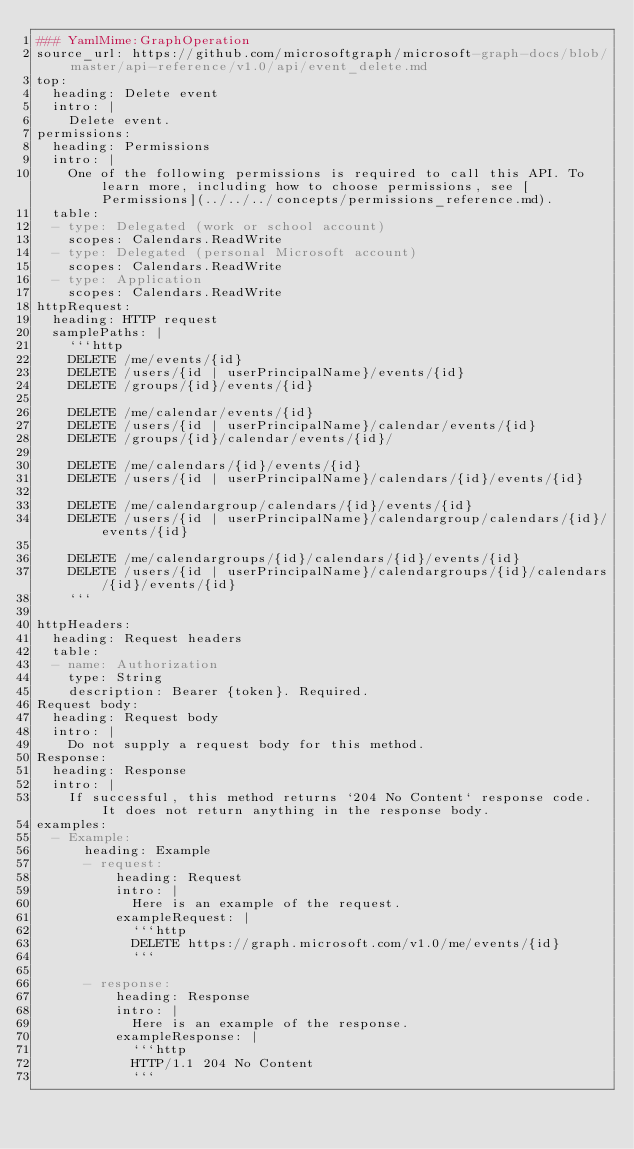Convert code to text. <code><loc_0><loc_0><loc_500><loc_500><_YAML_>### YamlMime:GraphOperation
source_url: https://github.com/microsoftgraph/microsoft-graph-docs/blob/master/api-reference/v1.0/api/event_delete.md
top:
  heading: Delete event
  intro: |
    Delete event.
permissions:
  heading: Permissions
  intro: |
    One of the following permissions is required to call this API. To learn more, including how to choose permissions, see [Permissions](../../../concepts/permissions_reference.md).
  table:
  - type: Delegated (work or school account)
    scopes: Calendars.ReadWrite
  - type: Delegated (personal Microsoft account)
    scopes: Calendars.ReadWrite
  - type: Application
    scopes: Calendars.ReadWrite
httpRequest:
  heading: HTTP request
  samplePaths: |
    ```http
    DELETE /me/events/{id}
    DELETE /users/{id | userPrincipalName}/events/{id}
    DELETE /groups/{id}/events/{id}
    
    DELETE /me/calendar/events/{id}
    DELETE /users/{id | userPrincipalName}/calendar/events/{id}
    DELETE /groups/{id}/calendar/events/{id}/
    
    DELETE /me/calendars/{id}/events/{id}
    DELETE /users/{id | userPrincipalName}/calendars/{id}/events/{id}
    
    DELETE /me/calendargroup/calendars/{id}/events/{id}
    DELETE /users/{id | userPrincipalName}/calendargroup/calendars/{id}/events/{id}
    
    DELETE /me/calendargroups/{id}/calendars/{id}/events/{id}
    DELETE /users/{id | userPrincipalName}/calendargroups/{id}/calendars/{id}/events/{id}
    ```
    
httpHeaders:
  heading: Request headers
  table:
  - name: Authorization
    type: String
    description: Bearer {token}. Required.
Request body:
  heading: Request body
  intro: |
    Do not supply a request body for this method.
Response:
  heading: Response
  intro: |
    If successful, this method returns `204 No Content` response code. It does not return anything in the response body.
examples:
  - Example:
      heading: Example
      - request:
          heading: Request
          intro: |
            Here is an example of the request.
          exampleRequest: |
            ```http
            DELETE https://graph.microsoft.com/v1.0/me/events/{id}
            ```
            
      - response:
          heading: Response
          intro: |
            Here is an example of the response. 
          exampleResponse: |
            ```http
            HTTP/1.1 204 No Content
            ```
            
</code> 